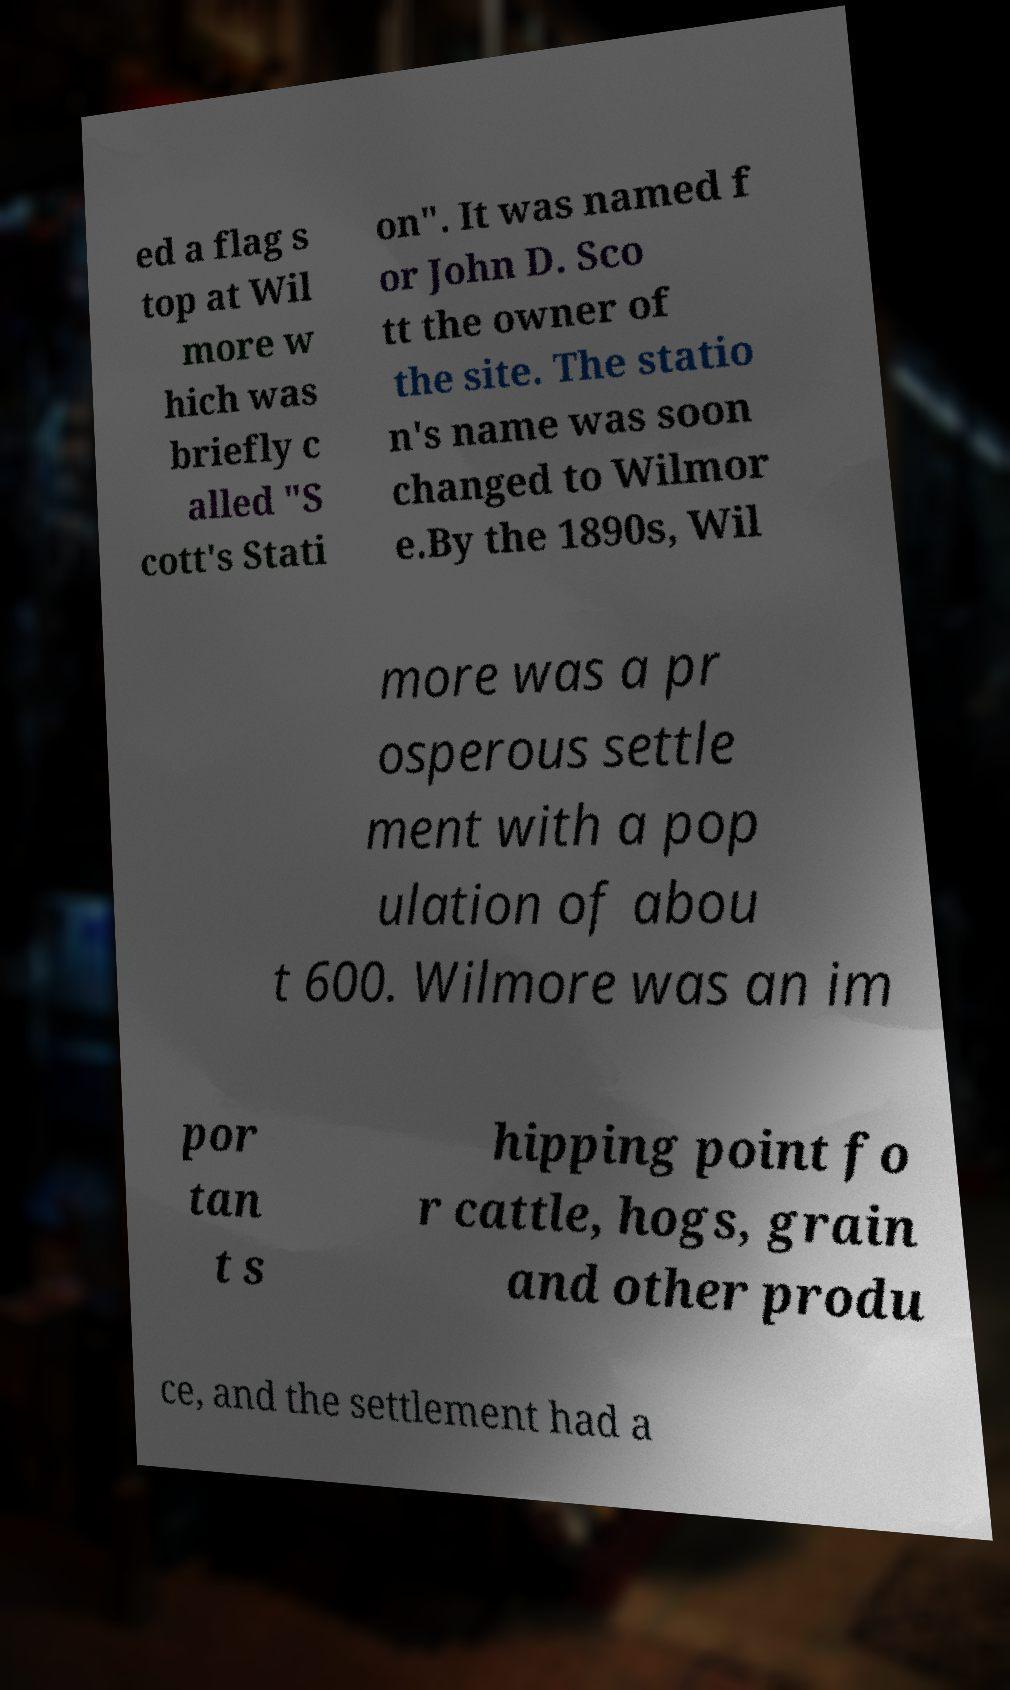There's text embedded in this image that I need extracted. Can you transcribe it verbatim? ed a flag s top at Wil more w hich was briefly c alled "S cott's Stati on". It was named f or John D. Sco tt the owner of the site. The statio n's name was soon changed to Wilmor e.By the 1890s, Wil more was a pr osperous settle ment with a pop ulation of abou t 600. Wilmore was an im por tan t s hipping point fo r cattle, hogs, grain and other produ ce, and the settlement had a 